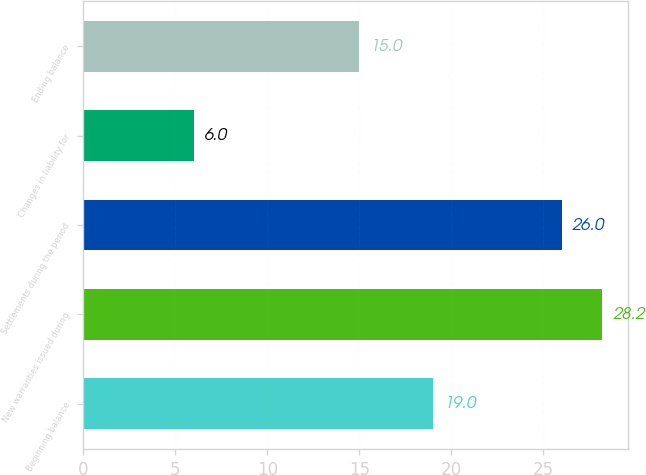<chart> <loc_0><loc_0><loc_500><loc_500><bar_chart><fcel>Beginning balance<fcel>New warranties issued during<fcel>Settlements during the period<fcel>Changes in liability for<fcel>Ending balance<nl><fcel>19<fcel>28.2<fcel>26<fcel>6<fcel>15<nl></chart> 